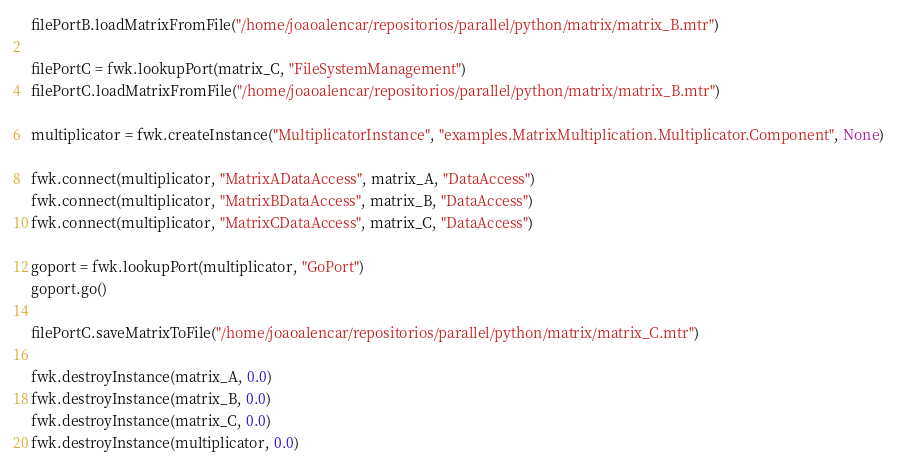Convert code to text. <code><loc_0><loc_0><loc_500><loc_500><_Python_>filePortB.loadMatrixFromFile("/home/joaoalencar/repositorios/parallel/python/matrix/matrix_B.mtr")

filePortC = fwk.lookupPort(matrix_C, "FileSystemManagement")   
filePortC.loadMatrixFromFile("/home/joaoalencar/repositorios/parallel/python/matrix/matrix_B.mtr")

multiplicator = fwk.createInstance("MultiplicatorInstance", "examples.MatrixMultiplication.Multiplicator.Component", None)

fwk.connect(multiplicator, "MatrixADataAccess", matrix_A, "DataAccess") 
fwk.connect(multiplicator, "MatrixBDataAccess", matrix_B, "DataAccess")
fwk.connect(multiplicator, "MatrixCDataAccess", matrix_C, "DataAccess")

goport = fwk.lookupPort(multiplicator, "GoPort")
goport.go()

filePortC.saveMatrixToFile("/home/joaoalencar/repositorios/parallel/python/matrix/matrix_C.mtr")

fwk.destroyInstance(matrix_A, 0.0)
fwk.destroyInstance(matrix_B, 0.0)
fwk.destroyInstance(matrix_C, 0.0)
fwk.destroyInstance(multiplicator, 0.0)

</code> 